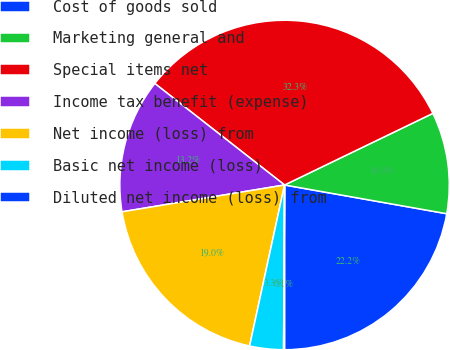Convert chart. <chart><loc_0><loc_0><loc_500><loc_500><pie_chart><fcel>Cost of goods sold<fcel>Marketing general and<fcel>Special items net<fcel>Income tax benefit (expense)<fcel>Net income (loss) from<fcel>Basic net income (loss)<fcel>Diluted net income (loss) from<nl><fcel>22.21%<fcel>9.95%<fcel>32.27%<fcel>13.17%<fcel>18.99%<fcel>3.31%<fcel>0.09%<nl></chart> 